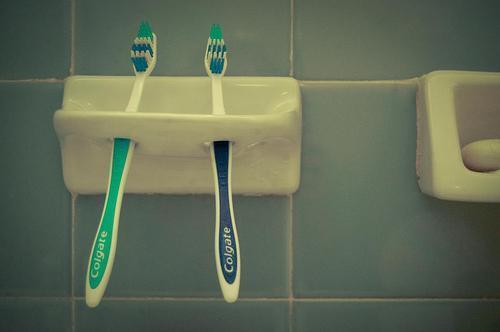How many toothbrushes are there?
Give a very brief answer. 2. How many toothbrushes are visible?
Give a very brief answer. 2. How many people can be seen?
Give a very brief answer. 0. 